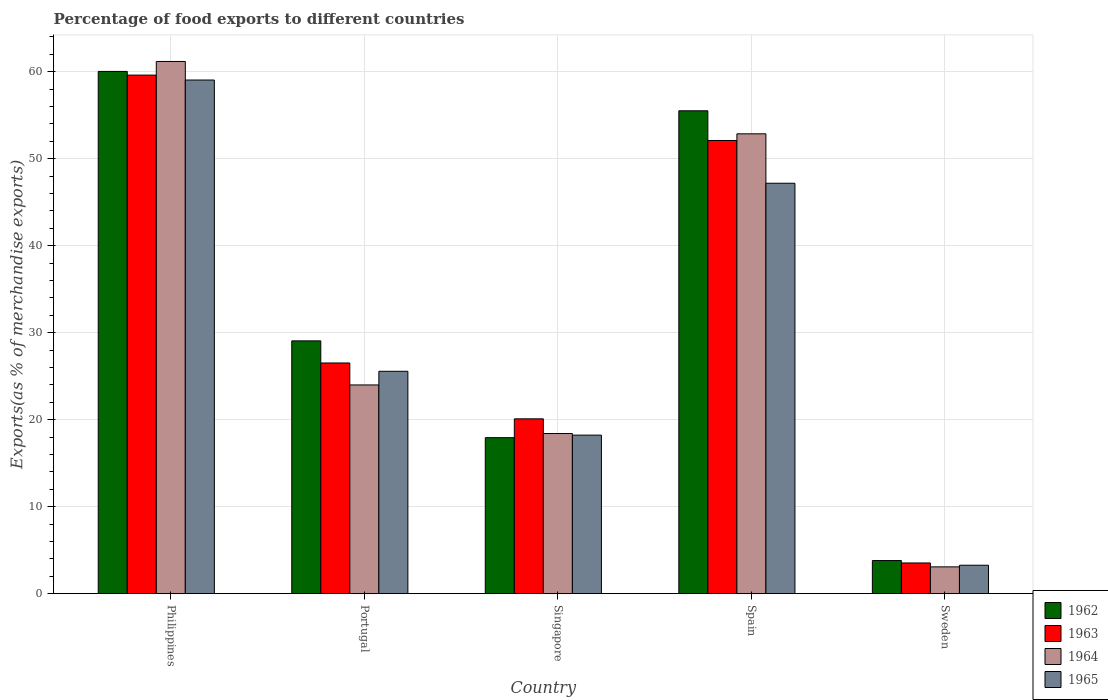How many different coloured bars are there?
Ensure brevity in your answer.  4. Are the number of bars on each tick of the X-axis equal?
Provide a short and direct response. Yes. How many bars are there on the 5th tick from the left?
Your answer should be compact. 4. How many bars are there on the 3rd tick from the right?
Make the answer very short. 4. In how many cases, is the number of bars for a given country not equal to the number of legend labels?
Your answer should be compact. 0. What is the percentage of exports to different countries in 1963 in Philippines?
Provide a succinct answer. 59.6. Across all countries, what is the maximum percentage of exports to different countries in 1962?
Ensure brevity in your answer.  60.03. Across all countries, what is the minimum percentage of exports to different countries in 1965?
Ensure brevity in your answer.  3.27. In which country was the percentage of exports to different countries in 1965 maximum?
Provide a short and direct response. Philippines. In which country was the percentage of exports to different countries in 1964 minimum?
Your response must be concise. Sweden. What is the total percentage of exports to different countries in 1965 in the graph?
Offer a very short reply. 153.26. What is the difference between the percentage of exports to different countries in 1965 in Singapore and that in Sweden?
Your response must be concise. 14.95. What is the difference between the percentage of exports to different countries in 1962 in Singapore and the percentage of exports to different countries in 1964 in Spain?
Your answer should be very brief. -34.92. What is the average percentage of exports to different countries in 1963 per country?
Ensure brevity in your answer.  32.36. What is the difference between the percentage of exports to different countries of/in 1963 and percentage of exports to different countries of/in 1965 in Singapore?
Provide a short and direct response. 1.87. In how many countries, is the percentage of exports to different countries in 1962 greater than 36 %?
Keep it short and to the point. 2. What is the ratio of the percentage of exports to different countries in 1965 in Portugal to that in Sweden?
Make the answer very short. 7.82. Is the percentage of exports to different countries in 1964 in Singapore less than that in Sweden?
Your response must be concise. No. Is the difference between the percentage of exports to different countries in 1963 in Philippines and Portugal greater than the difference between the percentage of exports to different countries in 1965 in Philippines and Portugal?
Make the answer very short. No. What is the difference between the highest and the second highest percentage of exports to different countries in 1964?
Your answer should be very brief. -8.31. What is the difference between the highest and the lowest percentage of exports to different countries in 1965?
Keep it short and to the point. 55.77. Is it the case that in every country, the sum of the percentage of exports to different countries in 1965 and percentage of exports to different countries in 1964 is greater than the sum of percentage of exports to different countries in 1963 and percentage of exports to different countries in 1962?
Your answer should be very brief. No. What does the 2nd bar from the left in Singapore represents?
Offer a very short reply. 1963. Are all the bars in the graph horizontal?
Offer a terse response. No. How many countries are there in the graph?
Provide a succinct answer. 5. What is the difference between two consecutive major ticks on the Y-axis?
Your response must be concise. 10. Does the graph contain any zero values?
Your response must be concise. No. Does the graph contain grids?
Make the answer very short. Yes. Where does the legend appear in the graph?
Offer a terse response. Bottom right. What is the title of the graph?
Ensure brevity in your answer.  Percentage of food exports to different countries. What is the label or title of the Y-axis?
Keep it short and to the point. Exports(as % of merchandise exports). What is the Exports(as % of merchandise exports) in 1962 in Philippines?
Offer a very short reply. 60.03. What is the Exports(as % of merchandise exports) of 1963 in Philippines?
Keep it short and to the point. 59.6. What is the Exports(as % of merchandise exports) in 1964 in Philippines?
Provide a short and direct response. 61.17. What is the Exports(as % of merchandise exports) of 1965 in Philippines?
Provide a short and direct response. 59.04. What is the Exports(as % of merchandise exports) in 1962 in Portugal?
Make the answer very short. 29.05. What is the Exports(as % of merchandise exports) in 1963 in Portugal?
Your response must be concise. 26.51. What is the Exports(as % of merchandise exports) of 1964 in Portugal?
Provide a short and direct response. 23.99. What is the Exports(as % of merchandise exports) of 1965 in Portugal?
Ensure brevity in your answer.  25.56. What is the Exports(as % of merchandise exports) of 1962 in Singapore?
Make the answer very short. 17.93. What is the Exports(as % of merchandise exports) of 1963 in Singapore?
Make the answer very short. 20.09. What is the Exports(as % of merchandise exports) of 1964 in Singapore?
Your response must be concise. 18.41. What is the Exports(as % of merchandise exports) of 1965 in Singapore?
Keep it short and to the point. 18.22. What is the Exports(as % of merchandise exports) of 1962 in Spain?
Offer a terse response. 55.5. What is the Exports(as % of merchandise exports) of 1963 in Spain?
Your answer should be very brief. 52.09. What is the Exports(as % of merchandise exports) in 1964 in Spain?
Offer a terse response. 52.85. What is the Exports(as % of merchandise exports) of 1965 in Spain?
Give a very brief answer. 47.17. What is the Exports(as % of merchandise exports) in 1962 in Sweden?
Provide a succinct answer. 3.8. What is the Exports(as % of merchandise exports) in 1963 in Sweden?
Your answer should be very brief. 3.53. What is the Exports(as % of merchandise exports) in 1964 in Sweden?
Offer a terse response. 3.08. What is the Exports(as % of merchandise exports) of 1965 in Sweden?
Ensure brevity in your answer.  3.27. Across all countries, what is the maximum Exports(as % of merchandise exports) in 1962?
Your answer should be very brief. 60.03. Across all countries, what is the maximum Exports(as % of merchandise exports) in 1963?
Make the answer very short. 59.6. Across all countries, what is the maximum Exports(as % of merchandise exports) of 1964?
Keep it short and to the point. 61.17. Across all countries, what is the maximum Exports(as % of merchandise exports) in 1965?
Keep it short and to the point. 59.04. Across all countries, what is the minimum Exports(as % of merchandise exports) in 1962?
Your answer should be compact. 3.8. Across all countries, what is the minimum Exports(as % of merchandise exports) in 1963?
Ensure brevity in your answer.  3.53. Across all countries, what is the minimum Exports(as % of merchandise exports) of 1964?
Your answer should be very brief. 3.08. Across all countries, what is the minimum Exports(as % of merchandise exports) of 1965?
Your answer should be very brief. 3.27. What is the total Exports(as % of merchandise exports) in 1962 in the graph?
Ensure brevity in your answer.  166.32. What is the total Exports(as % of merchandise exports) in 1963 in the graph?
Offer a very short reply. 161.82. What is the total Exports(as % of merchandise exports) of 1964 in the graph?
Provide a short and direct response. 159.49. What is the total Exports(as % of merchandise exports) of 1965 in the graph?
Make the answer very short. 153.26. What is the difference between the Exports(as % of merchandise exports) in 1962 in Philippines and that in Portugal?
Your answer should be compact. 30.97. What is the difference between the Exports(as % of merchandise exports) in 1963 in Philippines and that in Portugal?
Your answer should be very brief. 33.09. What is the difference between the Exports(as % of merchandise exports) of 1964 in Philippines and that in Portugal?
Offer a very short reply. 37.18. What is the difference between the Exports(as % of merchandise exports) in 1965 in Philippines and that in Portugal?
Give a very brief answer. 33.48. What is the difference between the Exports(as % of merchandise exports) in 1962 in Philippines and that in Singapore?
Make the answer very short. 42.1. What is the difference between the Exports(as % of merchandise exports) in 1963 in Philippines and that in Singapore?
Your response must be concise. 39.51. What is the difference between the Exports(as % of merchandise exports) in 1964 in Philippines and that in Singapore?
Ensure brevity in your answer.  42.76. What is the difference between the Exports(as % of merchandise exports) of 1965 in Philippines and that in Singapore?
Keep it short and to the point. 40.81. What is the difference between the Exports(as % of merchandise exports) of 1962 in Philippines and that in Spain?
Your answer should be compact. 4.53. What is the difference between the Exports(as % of merchandise exports) in 1963 in Philippines and that in Spain?
Give a very brief answer. 7.52. What is the difference between the Exports(as % of merchandise exports) in 1964 in Philippines and that in Spain?
Ensure brevity in your answer.  8.31. What is the difference between the Exports(as % of merchandise exports) in 1965 in Philippines and that in Spain?
Your response must be concise. 11.86. What is the difference between the Exports(as % of merchandise exports) of 1962 in Philippines and that in Sweden?
Offer a terse response. 56.22. What is the difference between the Exports(as % of merchandise exports) of 1963 in Philippines and that in Sweden?
Make the answer very short. 56.07. What is the difference between the Exports(as % of merchandise exports) in 1964 in Philippines and that in Sweden?
Your answer should be compact. 58.09. What is the difference between the Exports(as % of merchandise exports) of 1965 in Philippines and that in Sweden?
Give a very brief answer. 55.77. What is the difference between the Exports(as % of merchandise exports) in 1962 in Portugal and that in Singapore?
Make the answer very short. 11.12. What is the difference between the Exports(as % of merchandise exports) of 1963 in Portugal and that in Singapore?
Your answer should be compact. 6.42. What is the difference between the Exports(as % of merchandise exports) in 1964 in Portugal and that in Singapore?
Your answer should be compact. 5.58. What is the difference between the Exports(as % of merchandise exports) in 1965 in Portugal and that in Singapore?
Ensure brevity in your answer.  7.34. What is the difference between the Exports(as % of merchandise exports) of 1962 in Portugal and that in Spain?
Ensure brevity in your answer.  -26.45. What is the difference between the Exports(as % of merchandise exports) of 1963 in Portugal and that in Spain?
Your answer should be compact. -25.57. What is the difference between the Exports(as % of merchandise exports) of 1964 in Portugal and that in Spain?
Your answer should be compact. -28.86. What is the difference between the Exports(as % of merchandise exports) of 1965 in Portugal and that in Spain?
Make the answer very short. -21.61. What is the difference between the Exports(as % of merchandise exports) of 1962 in Portugal and that in Sweden?
Keep it short and to the point. 25.25. What is the difference between the Exports(as % of merchandise exports) in 1963 in Portugal and that in Sweden?
Make the answer very short. 22.98. What is the difference between the Exports(as % of merchandise exports) in 1964 in Portugal and that in Sweden?
Your response must be concise. 20.91. What is the difference between the Exports(as % of merchandise exports) of 1965 in Portugal and that in Sweden?
Offer a terse response. 22.29. What is the difference between the Exports(as % of merchandise exports) of 1962 in Singapore and that in Spain?
Give a very brief answer. -37.57. What is the difference between the Exports(as % of merchandise exports) in 1963 in Singapore and that in Spain?
Offer a terse response. -31.99. What is the difference between the Exports(as % of merchandise exports) in 1964 in Singapore and that in Spain?
Ensure brevity in your answer.  -34.45. What is the difference between the Exports(as % of merchandise exports) in 1965 in Singapore and that in Spain?
Your answer should be compact. -28.95. What is the difference between the Exports(as % of merchandise exports) in 1962 in Singapore and that in Sweden?
Your answer should be compact. 14.13. What is the difference between the Exports(as % of merchandise exports) of 1963 in Singapore and that in Sweden?
Provide a succinct answer. 16.56. What is the difference between the Exports(as % of merchandise exports) in 1964 in Singapore and that in Sweden?
Offer a terse response. 15.33. What is the difference between the Exports(as % of merchandise exports) of 1965 in Singapore and that in Sweden?
Provide a succinct answer. 14.95. What is the difference between the Exports(as % of merchandise exports) in 1962 in Spain and that in Sweden?
Provide a succinct answer. 51.7. What is the difference between the Exports(as % of merchandise exports) of 1963 in Spain and that in Sweden?
Keep it short and to the point. 48.56. What is the difference between the Exports(as % of merchandise exports) in 1964 in Spain and that in Sweden?
Offer a terse response. 49.77. What is the difference between the Exports(as % of merchandise exports) in 1965 in Spain and that in Sweden?
Give a very brief answer. 43.9. What is the difference between the Exports(as % of merchandise exports) of 1962 in Philippines and the Exports(as % of merchandise exports) of 1963 in Portugal?
Keep it short and to the point. 33.51. What is the difference between the Exports(as % of merchandise exports) in 1962 in Philippines and the Exports(as % of merchandise exports) in 1964 in Portugal?
Ensure brevity in your answer.  36.04. What is the difference between the Exports(as % of merchandise exports) in 1962 in Philippines and the Exports(as % of merchandise exports) in 1965 in Portugal?
Your response must be concise. 34.47. What is the difference between the Exports(as % of merchandise exports) in 1963 in Philippines and the Exports(as % of merchandise exports) in 1964 in Portugal?
Offer a terse response. 35.61. What is the difference between the Exports(as % of merchandise exports) of 1963 in Philippines and the Exports(as % of merchandise exports) of 1965 in Portugal?
Keep it short and to the point. 34.04. What is the difference between the Exports(as % of merchandise exports) in 1964 in Philippines and the Exports(as % of merchandise exports) in 1965 in Portugal?
Keep it short and to the point. 35.61. What is the difference between the Exports(as % of merchandise exports) in 1962 in Philippines and the Exports(as % of merchandise exports) in 1963 in Singapore?
Provide a succinct answer. 39.93. What is the difference between the Exports(as % of merchandise exports) in 1962 in Philippines and the Exports(as % of merchandise exports) in 1964 in Singapore?
Make the answer very short. 41.62. What is the difference between the Exports(as % of merchandise exports) of 1962 in Philippines and the Exports(as % of merchandise exports) of 1965 in Singapore?
Your answer should be very brief. 41.8. What is the difference between the Exports(as % of merchandise exports) in 1963 in Philippines and the Exports(as % of merchandise exports) in 1964 in Singapore?
Your answer should be very brief. 41.2. What is the difference between the Exports(as % of merchandise exports) of 1963 in Philippines and the Exports(as % of merchandise exports) of 1965 in Singapore?
Offer a very short reply. 41.38. What is the difference between the Exports(as % of merchandise exports) in 1964 in Philippines and the Exports(as % of merchandise exports) in 1965 in Singapore?
Your answer should be very brief. 42.95. What is the difference between the Exports(as % of merchandise exports) in 1962 in Philippines and the Exports(as % of merchandise exports) in 1963 in Spain?
Provide a succinct answer. 7.94. What is the difference between the Exports(as % of merchandise exports) in 1962 in Philippines and the Exports(as % of merchandise exports) in 1964 in Spain?
Your answer should be compact. 7.17. What is the difference between the Exports(as % of merchandise exports) of 1962 in Philippines and the Exports(as % of merchandise exports) of 1965 in Spain?
Offer a terse response. 12.85. What is the difference between the Exports(as % of merchandise exports) in 1963 in Philippines and the Exports(as % of merchandise exports) in 1964 in Spain?
Make the answer very short. 6.75. What is the difference between the Exports(as % of merchandise exports) in 1963 in Philippines and the Exports(as % of merchandise exports) in 1965 in Spain?
Keep it short and to the point. 12.43. What is the difference between the Exports(as % of merchandise exports) of 1964 in Philippines and the Exports(as % of merchandise exports) of 1965 in Spain?
Keep it short and to the point. 13.99. What is the difference between the Exports(as % of merchandise exports) in 1962 in Philippines and the Exports(as % of merchandise exports) in 1963 in Sweden?
Provide a succinct answer. 56.5. What is the difference between the Exports(as % of merchandise exports) of 1962 in Philippines and the Exports(as % of merchandise exports) of 1964 in Sweden?
Your answer should be compact. 56.95. What is the difference between the Exports(as % of merchandise exports) of 1962 in Philippines and the Exports(as % of merchandise exports) of 1965 in Sweden?
Your answer should be very brief. 56.76. What is the difference between the Exports(as % of merchandise exports) in 1963 in Philippines and the Exports(as % of merchandise exports) in 1964 in Sweden?
Ensure brevity in your answer.  56.52. What is the difference between the Exports(as % of merchandise exports) of 1963 in Philippines and the Exports(as % of merchandise exports) of 1965 in Sweden?
Your answer should be very brief. 56.33. What is the difference between the Exports(as % of merchandise exports) of 1964 in Philippines and the Exports(as % of merchandise exports) of 1965 in Sweden?
Provide a short and direct response. 57.9. What is the difference between the Exports(as % of merchandise exports) in 1962 in Portugal and the Exports(as % of merchandise exports) in 1963 in Singapore?
Your answer should be very brief. 8.96. What is the difference between the Exports(as % of merchandise exports) in 1962 in Portugal and the Exports(as % of merchandise exports) in 1964 in Singapore?
Your answer should be compact. 10.65. What is the difference between the Exports(as % of merchandise exports) of 1962 in Portugal and the Exports(as % of merchandise exports) of 1965 in Singapore?
Offer a very short reply. 10.83. What is the difference between the Exports(as % of merchandise exports) of 1963 in Portugal and the Exports(as % of merchandise exports) of 1964 in Singapore?
Offer a very short reply. 8.11. What is the difference between the Exports(as % of merchandise exports) in 1963 in Portugal and the Exports(as % of merchandise exports) in 1965 in Singapore?
Your response must be concise. 8.29. What is the difference between the Exports(as % of merchandise exports) of 1964 in Portugal and the Exports(as % of merchandise exports) of 1965 in Singapore?
Your answer should be compact. 5.77. What is the difference between the Exports(as % of merchandise exports) in 1962 in Portugal and the Exports(as % of merchandise exports) in 1963 in Spain?
Offer a terse response. -23.03. What is the difference between the Exports(as % of merchandise exports) of 1962 in Portugal and the Exports(as % of merchandise exports) of 1964 in Spain?
Your answer should be very brief. -23.8. What is the difference between the Exports(as % of merchandise exports) of 1962 in Portugal and the Exports(as % of merchandise exports) of 1965 in Spain?
Give a very brief answer. -18.12. What is the difference between the Exports(as % of merchandise exports) in 1963 in Portugal and the Exports(as % of merchandise exports) in 1964 in Spain?
Provide a short and direct response. -26.34. What is the difference between the Exports(as % of merchandise exports) in 1963 in Portugal and the Exports(as % of merchandise exports) in 1965 in Spain?
Your answer should be very brief. -20.66. What is the difference between the Exports(as % of merchandise exports) of 1964 in Portugal and the Exports(as % of merchandise exports) of 1965 in Spain?
Give a very brief answer. -23.18. What is the difference between the Exports(as % of merchandise exports) of 1962 in Portugal and the Exports(as % of merchandise exports) of 1963 in Sweden?
Provide a short and direct response. 25.53. What is the difference between the Exports(as % of merchandise exports) of 1962 in Portugal and the Exports(as % of merchandise exports) of 1964 in Sweden?
Your response must be concise. 25.98. What is the difference between the Exports(as % of merchandise exports) of 1962 in Portugal and the Exports(as % of merchandise exports) of 1965 in Sweden?
Ensure brevity in your answer.  25.79. What is the difference between the Exports(as % of merchandise exports) in 1963 in Portugal and the Exports(as % of merchandise exports) in 1964 in Sweden?
Your response must be concise. 23.44. What is the difference between the Exports(as % of merchandise exports) of 1963 in Portugal and the Exports(as % of merchandise exports) of 1965 in Sweden?
Your answer should be very brief. 23.25. What is the difference between the Exports(as % of merchandise exports) in 1964 in Portugal and the Exports(as % of merchandise exports) in 1965 in Sweden?
Offer a very short reply. 20.72. What is the difference between the Exports(as % of merchandise exports) in 1962 in Singapore and the Exports(as % of merchandise exports) in 1963 in Spain?
Offer a terse response. -34.16. What is the difference between the Exports(as % of merchandise exports) in 1962 in Singapore and the Exports(as % of merchandise exports) in 1964 in Spain?
Offer a terse response. -34.92. What is the difference between the Exports(as % of merchandise exports) of 1962 in Singapore and the Exports(as % of merchandise exports) of 1965 in Spain?
Keep it short and to the point. -29.24. What is the difference between the Exports(as % of merchandise exports) of 1963 in Singapore and the Exports(as % of merchandise exports) of 1964 in Spain?
Ensure brevity in your answer.  -32.76. What is the difference between the Exports(as % of merchandise exports) in 1963 in Singapore and the Exports(as % of merchandise exports) in 1965 in Spain?
Provide a short and direct response. -27.08. What is the difference between the Exports(as % of merchandise exports) in 1964 in Singapore and the Exports(as % of merchandise exports) in 1965 in Spain?
Give a very brief answer. -28.77. What is the difference between the Exports(as % of merchandise exports) in 1962 in Singapore and the Exports(as % of merchandise exports) in 1963 in Sweden?
Give a very brief answer. 14.4. What is the difference between the Exports(as % of merchandise exports) in 1962 in Singapore and the Exports(as % of merchandise exports) in 1964 in Sweden?
Ensure brevity in your answer.  14.85. What is the difference between the Exports(as % of merchandise exports) of 1962 in Singapore and the Exports(as % of merchandise exports) of 1965 in Sweden?
Provide a succinct answer. 14.66. What is the difference between the Exports(as % of merchandise exports) of 1963 in Singapore and the Exports(as % of merchandise exports) of 1964 in Sweden?
Provide a short and direct response. 17.01. What is the difference between the Exports(as % of merchandise exports) of 1963 in Singapore and the Exports(as % of merchandise exports) of 1965 in Sweden?
Give a very brief answer. 16.83. What is the difference between the Exports(as % of merchandise exports) in 1964 in Singapore and the Exports(as % of merchandise exports) in 1965 in Sweden?
Provide a short and direct response. 15.14. What is the difference between the Exports(as % of merchandise exports) of 1962 in Spain and the Exports(as % of merchandise exports) of 1963 in Sweden?
Your answer should be compact. 51.97. What is the difference between the Exports(as % of merchandise exports) in 1962 in Spain and the Exports(as % of merchandise exports) in 1964 in Sweden?
Give a very brief answer. 52.42. What is the difference between the Exports(as % of merchandise exports) in 1962 in Spain and the Exports(as % of merchandise exports) in 1965 in Sweden?
Your response must be concise. 52.23. What is the difference between the Exports(as % of merchandise exports) of 1963 in Spain and the Exports(as % of merchandise exports) of 1964 in Sweden?
Make the answer very short. 49.01. What is the difference between the Exports(as % of merchandise exports) of 1963 in Spain and the Exports(as % of merchandise exports) of 1965 in Sweden?
Ensure brevity in your answer.  48.82. What is the difference between the Exports(as % of merchandise exports) in 1964 in Spain and the Exports(as % of merchandise exports) in 1965 in Sweden?
Your answer should be very brief. 49.58. What is the average Exports(as % of merchandise exports) of 1962 per country?
Give a very brief answer. 33.26. What is the average Exports(as % of merchandise exports) of 1963 per country?
Your answer should be compact. 32.36. What is the average Exports(as % of merchandise exports) in 1964 per country?
Offer a terse response. 31.9. What is the average Exports(as % of merchandise exports) in 1965 per country?
Offer a terse response. 30.65. What is the difference between the Exports(as % of merchandise exports) in 1962 and Exports(as % of merchandise exports) in 1963 in Philippines?
Offer a terse response. 0.42. What is the difference between the Exports(as % of merchandise exports) in 1962 and Exports(as % of merchandise exports) in 1964 in Philippines?
Your response must be concise. -1.14. What is the difference between the Exports(as % of merchandise exports) in 1962 and Exports(as % of merchandise exports) in 1965 in Philippines?
Your answer should be very brief. 0.99. What is the difference between the Exports(as % of merchandise exports) of 1963 and Exports(as % of merchandise exports) of 1964 in Philippines?
Your answer should be very brief. -1.57. What is the difference between the Exports(as % of merchandise exports) of 1963 and Exports(as % of merchandise exports) of 1965 in Philippines?
Provide a short and direct response. 0.57. What is the difference between the Exports(as % of merchandise exports) in 1964 and Exports(as % of merchandise exports) in 1965 in Philippines?
Give a very brief answer. 2.13. What is the difference between the Exports(as % of merchandise exports) in 1962 and Exports(as % of merchandise exports) in 1963 in Portugal?
Provide a succinct answer. 2.54. What is the difference between the Exports(as % of merchandise exports) of 1962 and Exports(as % of merchandise exports) of 1964 in Portugal?
Make the answer very short. 5.06. What is the difference between the Exports(as % of merchandise exports) in 1962 and Exports(as % of merchandise exports) in 1965 in Portugal?
Give a very brief answer. 3.49. What is the difference between the Exports(as % of merchandise exports) of 1963 and Exports(as % of merchandise exports) of 1964 in Portugal?
Make the answer very short. 2.52. What is the difference between the Exports(as % of merchandise exports) of 1963 and Exports(as % of merchandise exports) of 1965 in Portugal?
Offer a terse response. 0.95. What is the difference between the Exports(as % of merchandise exports) of 1964 and Exports(as % of merchandise exports) of 1965 in Portugal?
Offer a very short reply. -1.57. What is the difference between the Exports(as % of merchandise exports) of 1962 and Exports(as % of merchandise exports) of 1963 in Singapore?
Keep it short and to the point. -2.16. What is the difference between the Exports(as % of merchandise exports) in 1962 and Exports(as % of merchandise exports) in 1964 in Singapore?
Your response must be concise. -0.48. What is the difference between the Exports(as % of merchandise exports) of 1962 and Exports(as % of merchandise exports) of 1965 in Singapore?
Provide a succinct answer. -0.29. What is the difference between the Exports(as % of merchandise exports) in 1963 and Exports(as % of merchandise exports) in 1964 in Singapore?
Offer a terse response. 1.69. What is the difference between the Exports(as % of merchandise exports) of 1963 and Exports(as % of merchandise exports) of 1965 in Singapore?
Make the answer very short. 1.87. What is the difference between the Exports(as % of merchandise exports) in 1964 and Exports(as % of merchandise exports) in 1965 in Singapore?
Give a very brief answer. 0.18. What is the difference between the Exports(as % of merchandise exports) of 1962 and Exports(as % of merchandise exports) of 1963 in Spain?
Your response must be concise. 3.42. What is the difference between the Exports(as % of merchandise exports) in 1962 and Exports(as % of merchandise exports) in 1964 in Spain?
Give a very brief answer. 2.65. What is the difference between the Exports(as % of merchandise exports) of 1962 and Exports(as % of merchandise exports) of 1965 in Spain?
Your response must be concise. 8.33. What is the difference between the Exports(as % of merchandise exports) of 1963 and Exports(as % of merchandise exports) of 1964 in Spain?
Your answer should be very brief. -0.77. What is the difference between the Exports(as % of merchandise exports) in 1963 and Exports(as % of merchandise exports) in 1965 in Spain?
Your answer should be very brief. 4.91. What is the difference between the Exports(as % of merchandise exports) in 1964 and Exports(as % of merchandise exports) in 1965 in Spain?
Your answer should be compact. 5.68. What is the difference between the Exports(as % of merchandise exports) of 1962 and Exports(as % of merchandise exports) of 1963 in Sweden?
Your answer should be compact. 0.28. What is the difference between the Exports(as % of merchandise exports) in 1962 and Exports(as % of merchandise exports) in 1964 in Sweden?
Provide a succinct answer. 0.73. What is the difference between the Exports(as % of merchandise exports) in 1962 and Exports(as % of merchandise exports) in 1965 in Sweden?
Give a very brief answer. 0.54. What is the difference between the Exports(as % of merchandise exports) in 1963 and Exports(as % of merchandise exports) in 1964 in Sweden?
Provide a succinct answer. 0.45. What is the difference between the Exports(as % of merchandise exports) in 1963 and Exports(as % of merchandise exports) in 1965 in Sweden?
Your response must be concise. 0.26. What is the difference between the Exports(as % of merchandise exports) of 1964 and Exports(as % of merchandise exports) of 1965 in Sweden?
Your answer should be compact. -0.19. What is the ratio of the Exports(as % of merchandise exports) in 1962 in Philippines to that in Portugal?
Provide a succinct answer. 2.07. What is the ratio of the Exports(as % of merchandise exports) in 1963 in Philippines to that in Portugal?
Offer a terse response. 2.25. What is the ratio of the Exports(as % of merchandise exports) in 1964 in Philippines to that in Portugal?
Provide a short and direct response. 2.55. What is the ratio of the Exports(as % of merchandise exports) in 1965 in Philippines to that in Portugal?
Provide a short and direct response. 2.31. What is the ratio of the Exports(as % of merchandise exports) in 1962 in Philippines to that in Singapore?
Provide a short and direct response. 3.35. What is the ratio of the Exports(as % of merchandise exports) of 1963 in Philippines to that in Singapore?
Give a very brief answer. 2.97. What is the ratio of the Exports(as % of merchandise exports) of 1964 in Philippines to that in Singapore?
Ensure brevity in your answer.  3.32. What is the ratio of the Exports(as % of merchandise exports) in 1965 in Philippines to that in Singapore?
Make the answer very short. 3.24. What is the ratio of the Exports(as % of merchandise exports) in 1962 in Philippines to that in Spain?
Offer a terse response. 1.08. What is the ratio of the Exports(as % of merchandise exports) in 1963 in Philippines to that in Spain?
Offer a very short reply. 1.14. What is the ratio of the Exports(as % of merchandise exports) in 1964 in Philippines to that in Spain?
Your response must be concise. 1.16. What is the ratio of the Exports(as % of merchandise exports) in 1965 in Philippines to that in Spain?
Make the answer very short. 1.25. What is the ratio of the Exports(as % of merchandise exports) in 1962 in Philippines to that in Sweden?
Your answer should be very brief. 15.78. What is the ratio of the Exports(as % of merchandise exports) of 1963 in Philippines to that in Sweden?
Keep it short and to the point. 16.89. What is the ratio of the Exports(as % of merchandise exports) in 1964 in Philippines to that in Sweden?
Offer a very short reply. 19.87. What is the ratio of the Exports(as % of merchandise exports) of 1965 in Philippines to that in Sweden?
Provide a short and direct response. 18.07. What is the ratio of the Exports(as % of merchandise exports) of 1962 in Portugal to that in Singapore?
Provide a short and direct response. 1.62. What is the ratio of the Exports(as % of merchandise exports) of 1963 in Portugal to that in Singapore?
Your answer should be very brief. 1.32. What is the ratio of the Exports(as % of merchandise exports) of 1964 in Portugal to that in Singapore?
Your answer should be compact. 1.3. What is the ratio of the Exports(as % of merchandise exports) of 1965 in Portugal to that in Singapore?
Ensure brevity in your answer.  1.4. What is the ratio of the Exports(as % of merchandise exports) of 1962 in Portugal to that in Spain?
Your response must be concise. 0.52. What is the ratio of the Exports(as % of merchandise exports) in 1963 in Portugal to that in Spain?
Your answer should be very brief. 0.51. What is the ratio of the Exports(as % of merchandise exports) of 1964 in Portugal to that in Spain?
Provide a short and direct response. 0.45. What is the ratio of the Exports(as % of merchandise exports) in 1965 in Portugal to that in Spain?
Your response must be concise. 0.54. What is the ratio of the Exports(as % of merchandise exports) of 1962 in Portugal to that in Sweden?
Offer a very short reply. 7.64. What is the ratio of the Exports(as % of merchandise exports) of 1963 in Portugal to that in Sweden?
Provide a succinct answer. 7.51. What is the ratio of the Exports(as % of merchandise exports) of 1964 in Portugal to that in Sweden?
Your answer should be very brief. 7.79. What is the ratio of the Exports(as % of merchandise exports) in 1965 in Portugal to that in Sweden?
Provide a succinct answer. 7.82. What is the ratio of the Exports(as % of merchandise exports) in 1962 in Singapore to that in Spain?
Offer a very short reply. 0.32. What is the ratio of the Exports(as % of merchandise exports) in 1963 in Singapore to that in Spain?
Offer a very short reply. 0.39. What is the ratio of the Exports(as % of merchandise exports) in 1964 in Singapore to that in Spain?
Keep it short and to the point. 0.35. What is the ratio of the Exports(as % of merchandise exports) in 1965 in Singapore to that in Spain?
Provide a succinct answer. 0.39. What is the ratio of the Exports(as % of merchandise exports) in 1962 in Singapore to that in Sweden?
Provide a succinct answer. 4.71. What is the ratio of the Exports(as % of merchandise exports) of 1963 in Singapore to that in Sweden?
Your response must be concise. 5.69. What is the ratio of the Exports(as % of merchandise exports) in 1964 in Singapore to that in Sweden?
Provide a succinct answer. 5.98. What is the ratio of the Exports(as % of merchandise exports) of 1965 in Singapore to that in Sweden?
Give a very brief answer. 5.58. What is the ratio of the Exports(as % of merchandise exports) in 1962 in Spain to that in Sweden?
Your response must be concise. 14.59. What is the ratio of the Exports(as % of merchandise exports) in 1963 in Spain to that in Sweden?
Provide a succinct answer. 14.76. What is the ratio of the Exports(as % of merchandise exports) in 1964 in Spain to that in Sweden?
Keep it short and to the point. 17.17. What is the ratio of the Exports(as % of merchandise exports) in 1965 in Spain to that in Sweden?
Your answer should be very brief. 14.44. What is the difference between the highest and the second highest Exports(as % of merchandise exports) of 1962?
Offer a very short reply. 4.53. What is the difference between the highest and the second highest Exports(as % of merchandise exports) in 1963?
Your answer should be very brief. 7.52. What is the difference between the highest and the second highest Exports(as % of merchandise exports) of 1964?
Your answer should be compact. 8.31. What is the difference between the highest and the second highest Exports(as % of merchandise exports) in 1965?
Your answer should be very brief. 11.86. What is the difference between the highest and the lowest Exports(as % of merchandise exports) of 1962?
Your answer should be compact. 56.22. What is the difference between the highest and the lowest Exports(as % of merchandise exports) of 1963?
Provide a succinct answer. 56.07. What is the difference between the highest and the lowest Exports(as % of merchandise exports) of 1964?
Ensure brevity in your answer.  58.09. What is the difference between the highest and the lowest Exports(as % of merchandise exports) in 1965?
Your answer should be compact. 55.77. 